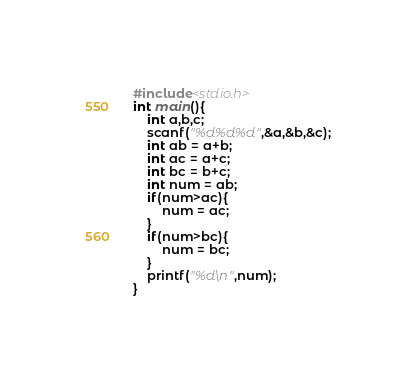Convert code to text. <code><loc_0><loc_0><loc_500><loc_500><_C_>#include<stdio.h>
int main(){
	int a,b,c;
	scanf("%d%d%d",&a,&b,&c);
	int ab = a+b;
	int ac = a+c;
	int bc = b+c;
	int num = ab;
	if(num>ac){
		num = ac;
	}
	if(num>bc){
		num = bc;
	}
	printf("%d\n",num);
}</code> 